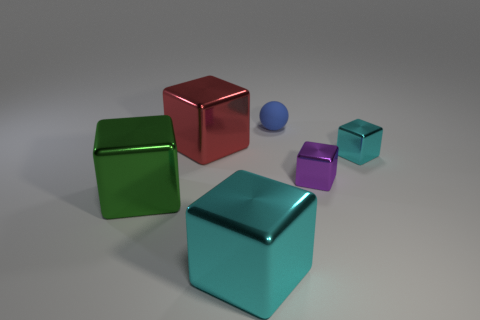Is there anything else that is made of the same material as the small blue object?
Offer a terse response. No. Is the number of blue balls that are to the left of the blue thing the same as the number of small blue things in front of the tiny cyan cube?
Ensure brevity in your answer.  Yes. How many cyan metallic objects have the same size as the red cube?
Offer a very short reply. 1. How many blue things are tiny matte balls or large shiny balls?
Give a very brief answer. 1. Is the number of blue balls that are left of the tiny blue matte sphere the same as the number of big red cylinders?
Your response must be concise. Yes. What is the size of the cyan metallic cube behind the big cyan shiny block?
Provide a succinct answer. Small. How many large cyan objects are the same shape as the small purple thing?
Offer a very short reply. 1. What material is the object that is behind the small cyan metallic object and left of the blue object?
Offer a very short reply. Metal. Are the blue ball and the red block made of the same material?
Your response must be concise. No. What number of tiny brown rubber blocks are there?
Provide a short and direct response. 0. 